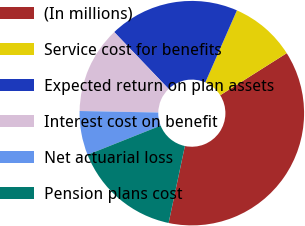<chart> <loc_0><loc_0><loc_500><loc_500><pie_chart><fcel>(In millions)<fcel>Service cost for benefits<fcel>Expected return on plan assets<fcel>Interest cost on benefit<fcel>Net actuarial loss<fcel>Pension plans cost<nl><fcel>37.29%<fcel>9.45%<fcel>18.73%<fcel>12.54%<fcel>6.35%<fcel>15.64%<nl></chart> 